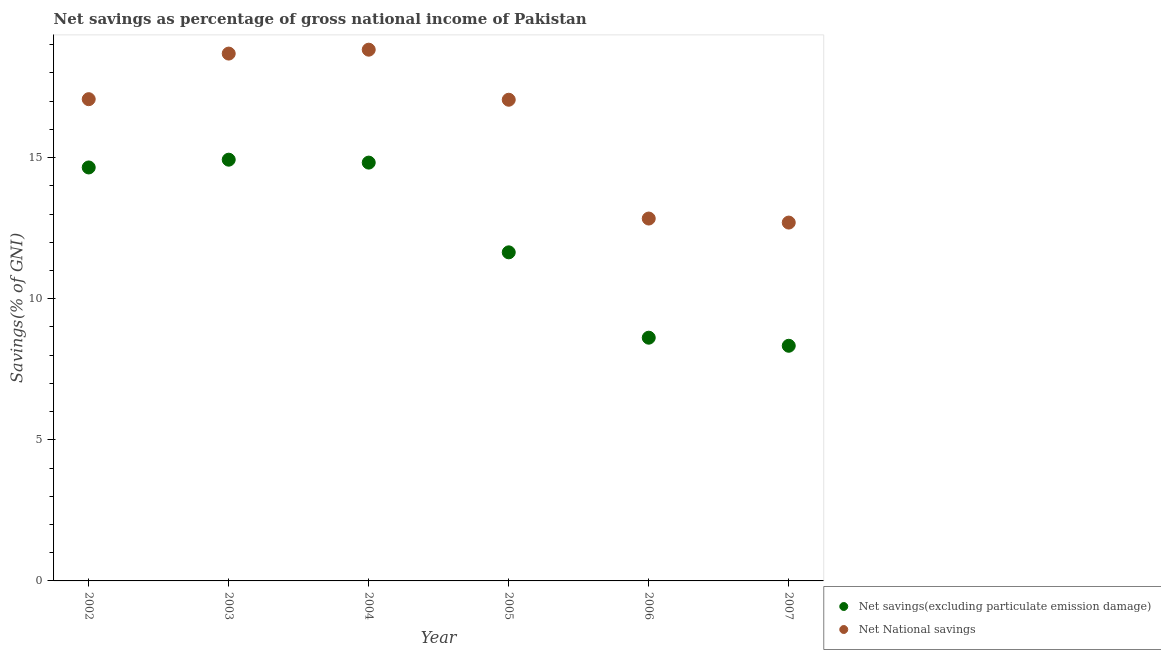Is the number of dotlines equal to the number of legend labels?
Give a very brief answer. Yes. What is the net national savings in 2005?
Offer a very short reply. 17.05. Across all years, what is the maximum net savings(excluding particulate emission damage)?
Offer a very short reply. 14.93. Across all years, what is the minimum net savings(excluding particulate emission damage)?
Offer a very short reply. 8.33. In which year was the net national savings maximum?
Offer a very short reply. 2004. What is the total net national savings in the graph?
Your answer should be compact. 97.18. What is the difference between the net savings(excluding particulate emission damage) in 2006 and that in 2007?
Your answer should be compact. 0.29. What is the difference between the net national savings in 2003 and the net savings(excluding particulate emission damage) in 2006?
Your response must be concise. 10.07. What is the average net savings(excluding particulate emission damage) per year?
Keep it short and to the point. 12.17. In the year 2002, what is the difference between the net national savings and net savings(excluding particulate emission damage)?
Your response must be concise. 2.42. In how many years, is the net national savings greater than 8 %?
Provide a succinct answer. 6. What is the ratio of the net national savings in 2002 to that in 2007?
Ensure brevity in your answer.  1.34. Is the net savings(excluding particulate emission damage) in 2002 less than that in 2007?
Provide a succinct answer. No. What is the difference between the highest and the second highest net savings(excluding particulate emission damage)?
Keep it short and to the point. 0.1. What is the difference between the highest and the lowest net savings(excluding particulate emission damage)?
Offer a very short reply. 6.59. In how many years, is the net savings(excluding particulate emission damage) greater than the average net savings(excluding particulate emission damage) taken over all years?
Give a very brief answer. 3. Does the net national savings monotonically increase over the years?
Give a very brief answer. No. Is the net national savings strictly less than the net savings(excluding particulate emission damage) over the years?
Keep it short and to the point. No. How many years are there in the graph?
Offer a very short reply. 6. What is the difference between two consecutive major ticks on the Y-axis?
Make the answer very short. 5. Are the values on the major ticks of Y-axis written in scientific E-notation?
Your answer should be compact. No. Does the graph contain any zero values?
Your answer should be very brief. No. Where does the legend appear in the graph?
Ensure brevity in your answer.  Bottom right. How are the legend labels stacked?
Your answer should be compact. Vertical. What is the title of the graph?
Provide a succinct answer. Net savings as percentage of gross national income of Pakistan. What is the label or title of the Y-axis?
Offer a very short reply. Savings(% of GNI). What is the Savings(% of GNI) in Net savings(excluding particulate emission damage) in 2002?
Ensure brevity in your answer.  14.65. What is the Savings(% of GNI) in Net National savings in 2002?
Your response must be concise. 17.07. What is the Savings(% of GNI) in Net savings(excluding particulate emission damage) in 2003?
Give a very brief answer. 14.93. What is the Savings(% of GNI) of Net National savings in 2003?
Your answer should be very brief. 18.69. What is the Savings(% of GNI) in Net savings(excluding particulate emission damage) in 2004?
Provide a succinct answer. 14.82. What is the Savings(% of GNI) in Net National savings in 2004?
Make the answer very short. 18.83. What is the Savings(% of GNI) in Net savings(excluding particulate emission damage) in 2005?
Offer a terse response. 11.64. What is the Savings(% of GNI) in Net National savings in 2005?
Make the answer very short. 17.05. What is the Savings(% of GNI) of Net savings(excluding particulate emission damage) in 2006?
Make the answer very short. 8.62. What is the Savings(% of GNI) in Net National savings in 2006?
Your response must be concise. 12.84. What is the Savings(% of GNI) of Net savings(excluding particulate emission damage) in 2007?
Keep it short and to the point. 8.33. What is the Savings(% of GNI) in Net National savings in 2007?
Offer a very short reply. 12.7. Across all years, what is the maximum Savings(% of GNI) in Net savings(excluding particulate emission damage)?
Offer a terse response. 14.93. Across all years, what is the maximum Savings(% of GNI) in Net National savings?
Provide a short and direct response. 18.83. Across all years, what is the minimum Savings(% of GNI) in Net savings(excluding particulate emission damage)?
Provide a short and direct response. 8.33. Across all years, what is the minimum Savings(% of GNI) of Net National savings?
Offer a terse response. 12.7. What is the total Savings(% of GNI) of Net savings(excluding particulate emission damage) in the graph?
Keep it short and to the point. 73. What is the total Savings(% of GNI) of Net National savings in the graph?
Ensure brevity in your answer.  97.18. What is the difference between the Savings(% of GNI) of Net savings(excluding particulate emission damage) in 2002 and that in 2003?
Make the answer very short. -0.28. What is the difference between the Savings(% of GNI) of Net National savings in 2002 and that in 2003?
Provide a succinct answer. -1.62. What is the difference between the Savings(% of GNI) of Net savings(excluding particulate emission damage) in 2002 and that in 2004?
Offer a very short reply. -0.17. What is the difference between the Savings(% of GNI) of Net National savings in 2002 and that in 2004?
Provide a succinct answer. -1.75. What is the difference between the Savings(% of GNI) of Net savings(excluding particulate emission damage) in 2002 and that in 2005?
Offer a very short reply. 3.01. What is the difference between the Savings(% of GNI) of Net National savings in 2002 and that in 2005?
Your answer should be compact. 0.02. What is the difference between the Savings(% of GNI) in Net savings(excluding particulate emission damage) in 2002 and that in 2006?
Provide a succinct answer. 6.03. What is the difference between the Savings(% of GNI) in Net National savings in 2002 and that in 2006?
Your response must be concise. 4.23. What is the difference between the Savings(% of GNI) in Net savings(excluding particulate emission damage) in 2002 and that in 2007?
Your answer should be compact. 6.32. What is the difference between the Savings(% of GNI) of Net National savings in 2002 and that in 2007?
Your answer should be compact. 4.37. What is the difference between the Savings(% of GNI) in Net savings(excluding particulate emission damage) in 2003 and that in 2004?
Your answer should be very brief. 0.1. What is the difference between the Savings(% of GNI) of Net National savings in 2003 and that in 2004?
Your response must be concise. -0.14. What is the difference between the Savings(% of GNI) of Net savings(excluding particulate emission damage) in 2003 and that in 2005?
Provide a short and direct response. 3.28. What is the difference between the Savings(% of GNI) in Net National savings in 2003 and that in 2005?
Provide a succinct answer. 1.64. What is the difference between the Savings(% of GNI) of Net savings(excluding particulate emission damage) in 2003 and that in 2006?
Offer a very short reply. 6.31. What is the difference between the Savings(% of GNI) of Net National savings in 2003 and that in 2006?
Your answer should be very brief. 5.85. What is the difference between the Savings(% of GNI) in Net savings(excluding particulate emission damage) in 2003 and that in 2007?
Offer a very short reply. 6.59. What is the difference between the Savings(% of GNI) in Net National savings in 2003 and that in 2007?
Offer a terse response. 5.99. What is the difference between the Savings(% of GNI) of Net savings(excluding particulate emission damage) in 2004 and that in 2005?
Offer a very short reply. 3.18. What is the difference between the Savings(% of GNI) of Net National savings in 2004 and that in 2005?
Offer a terse response. 1.77. What is the difference between the Savings(% of GNI) of Net savings(excluding particulate emission damage) in 2004 and that in 2006?
Your answer should be compact. 6.2. What is the difference between the Savings(% of GNI) in Net National savings in 2004 and that in 2006?
Keep it short and to the point. 5.98. What is the difference between the Savings(% of GNI) of Net savings(excluding particulate emission damage) in 2004 and that in 2007?
Give a very brief answer. 6.49. What is the difference between the Savings(% of GNI) in Net National savings in 2004 and that in 2007?
Keep it short and to the point. 6.13. What is the difference between the Savings(% of GNI) in Net savings(excluding particulate emission damage) in 2005 and that in 2006?
Keep it short and to the point. 3.02. What is the difference between the Savings(% of GNI) in Net National savings in 2005 and that in 2006?
Keep it short and to the point. 4.21. What is the difference between the Savings(% of GNI) in Net savings(excluding particulate emission damage) in 2005 and that in 2007?
Provide a short and direct response. 3.31. What is the difference between the Savings(% of GNI) of Net National savings in 2005 and that in 2007?
Ensure brevity in your answer.  4.35. What is the difference between the Savings(% of GNI) of Net savings(excluding particulate emission damage) in 2006 and that in 2007?
Provide a short and direct response. 0.29. What is the difference between the Savings(% of GNI) in Net National savings in 2006 and that in 2007?
Keep it short and to the point. 0.14. What is the difference between the Savings(% of GNI) of Net savings(excluding particulate emission damage) in 2002 and the Savings(% of GNI) of Net National savings in 2003?
Make the answer very short. -4.04. What is the difference between the Savings(% of GNI) in Net savings(excluding particulate emission damage) in 2002 and the Savings(% of GNI) in Net National savings in 2004?
Your answer should be compact. -4.17. What is the difference between the Savings(% of GNI) in Net savings(excluding particulate emission damage) in 2002 and the Savings(% of GNI) in Net National savings in 2005?
Offer a very short reply. -2.4. What is the difference between the Savings(% of GNI) in Net savings(excluding particulate emission damage) in 2002 and the Savings(% of GNI) in Net National savings in 2006?
Keep it short and to the point. 1.81. What is the difference between the Savings(% of GNI) of Net savings(excluding particulate emission damage) in 2002 and the Savings(% of GNI) of Net National savings in 2007?
Provide a short and direct response. 1.95. What is the difference between the Savings(% of GNI) of Net savings(excluding particulate emission damage) in 2003 and the Savings(% of GNI) of Net National savings in 2004?
Offer a terse response. -3.9. What is the difference between the Savings(% of GNI) of Net savings(excluding particulate emission damage) in 2003 and the Savings(% of GNI) of Net National savings in 2005?
Offer a terse response. -2.12. What is the difference between the Savings(% of GNI) in Net savings(excluding particulate emission damage) in 2003 and the Savings(% of GNI) in Net National savings in 2006?
Make the answer very short. 2.09. What is the difference between the Savings(% of GNI) in Net savings(excluding particulate emission damage) in 2003 and the Savings(% of GNI) in Net National savings in 2007?
Offer a terse response. 2.23. What is the difference between the Savings(% of GNI) in Net savings(excluding particulate emission damage) in 2004 and the Savings(% of GNI) in Net National savings in 2005?
Give a very brief answer. -2.23. What is the difference between the Savings(% of GNI) of Net savings(excluding particulate emission damage) in 2004 and the Savings(% of GNI) of Net National savings in 2006?
Provide a short and direct response. 1.98. What is the difference between the Savings(% of GNI) of Net savings(excluding particulate emission damage) in 2004 and the Savings(% of GNI) of Net National savings in 2007?
Your answer should be very brief. 2.13. What is the difference between the Savings(% of GNI) of Net savings(excluding particulate emission damage) in 2005 and the Savings(% of GNI) of Net National savings in 2006?
Make the answer very short. -1.2. What is the difference between the Savings(% of GNI) of Net savings(excluding particulate emission damage) in 2005 and the Savings(% of GNI) of Net National savings in 2007?
Give a very brief answer. -1.05. What is the difference between the Savings(% of GNI) of Net savings(excluding particulate emission damage) in 2006 and the Savings(% of GNI) of Net National savings in 2007?
Give a very brief answer. -4.08. What is the average Savings(% of GNI) in Net savings(excluding particulate emission damage) per year?
Provide a short and direct response. 12.17. What is the average Savings(% of GNI) of Net National savings per year?
Give a very brief answer. 16.2. In the year 2002, what is the difference between the Savings(% of GNI) of Net savings(excluding particulate emission damage) and Savings(% of GNI) of Net National savings?
Give a very brief answer. -2.42. In the year 2003, what is the difference between the Savings(% of GNI) in Net savings(excluding particulate emission damage) and Savings(% of GNI) in Net National savings?
Keep it short and to the point. -3.76. In the year 2004, what is the difference between the Savings(% of GNI) in Net savings(excluding particulate emission damage) and Savings(% of GNI) in Net National savings?
Keep it short and to the point. -4. In the year 2005, what is the difference between the Savings(% of GNI) of Net savings(excluding particulate emission damage) and Savings(% of GNI) of Net National savings?
Provide a short and direct response. -5.41. In the year 2006, what is the difference between the Savings(% of GNI) in Net savings(excluding particulate emission damage) and Savings(% of GNI) in Net National savings?
Your answer should be compact. -4.22. In the year 2007, what is the difference between the Savings(% of GNI) in Net savings(excluding particulate emission damage) and Savings(% of GNI) in Net National savings?
Make the answer very short. -4.37. What is the ratio of the Savings(% of GNI) of Net savings(excluding particulate emission damage) in 2002 to that in 2003?
Provide a short and direct response. 0.98. What is the ratio of the Savings(% of GNI) in Net National savings in 2002 to that in 2003?
Ensure brevity in your answer.  0.91. What is the ratio of the Savings(% of GNI) of Net savings(excluding particulate emission damage) in 2002 to that in 2004?
Give a very brief answer. 0.99. What is the ratio of the Savings(% of GNI) in Net National savings in 2002 to that in 2004?
Provide a succinct answer. 0.91. What is the ratio of the Savings(% of GNI) in Net savings(excluding particulate emission damage) in 2002 to that in 2005?
Your answer should be compact. 1.26. What is the ratio of the Savings(% of GNI) in Net National savings in 2002 to that in 2005?
Give a very brief answer. 1. What is the ratio of the Savings(% of GNI) in Net savings(excluding particulate emission damage) in 2002 to that in 2006?
Provide a short and direct response. 1.7. What is the ratio of the Savings(% of GNI) of Net National savings in 2002 to that in 2006?
Your answer should be compact. 1.33. What is the ratio of the Savings(% of GNI) of Net savings(excluding particulate emission damage) in 2002 to that in 2007?
Ensure brevity in your answer.  1.76. What is the ratio of the Savings(% of GNI) of Net National savings in 2002 to that in 2007?
Provide a short and direct response. 1.34. What is the ratio of the Savings(% of GNI) of Net National savings in 2003 to that in 2004?
Offer a very short reply. 0.99. What is the ratio of the Savings(% of GNI) of Net savings(excluding particulate emission damage) in 2003 to that in 2005?
Your answer should be compact. 1.28. What is the ratio of the Savings(% of GNI) in Net National savings in 2003 to that in 2005?
Give a very brief answer. 1.1. What is the ratio of the Savings(% of GNI) in Net savings(excluding particulate emission damage) in 2003 to that in 2006?
Give a very brief answer. 1.73. What is the ratio of the Savings(% of GNI) of Net National savings in 2003 to that in 2006?
Your response must be concise. 1.46. What is the ratio of the Savings(% of GNI) of Net savings(excluding particulate emission damage) in 2003 to that in 2007?
Your answer should be compact. 1.79. What is the ratio of the Savings(% of GNI) in Net National savings in 2003 to that in 2007?
Make the answer very short. 1.47. What is the ratio of the Savings(% of GNI) in Net savings(excluding particulate emission damage) in 2004 to that in 2005?
Offer a terse response. 1.27. What is the ratio of the Savings(% of GNI) in Net National savings in 2004 to that in 2005?
Your response must be concise. 1.1. What is the ratio of the Savings(% of GNI) in Net savings(excluding particulate emission damage) in 2004 to that in 2006?
Make the answer very short. 1.72. What is the ratio of the Savings(% of GNI) in Net National savings in 2004 to that in 2006?
Provide a short and direct response. 1.47. What is the ratio of the Savings(% of GNI) in Net savings(excluding particulate emission damage) in 2004 to that in 2007?
Your response must be concise. 1.78. What is the ratio of the Savings(% of GNI) in Net National savings in 2004 to that in 2007?
Give a very brief answer. 1.48. What is the ratio of the Savings(% of GNI) in Net savings(excluding particulate emission damage) in 2005 to that in 2006?
Keep it short and to the point. 1.35. What is the ratio of the Savings(% of GNI) of Net National savings in 2005 to that in 2006?
Your response must be concise. 1.33. What is the ratio of the Savings(% of GNI) in Net savings(excluding particulate emission damage) in 2005 to that in 2007?
Your answer should be very brief. 1.4. What is the ratio of the Savings(% of GNI) in Net National savings in 2005 to that in 2007?
Your response must be concise. 1.34. What is the ratio of the Savings(% of GNI) in Net savings(excluding particulate emission damage) in 2006 to that in 2007?
Offer a very short reply. 1.03. What is the ratio of the Savings(% of GNI) in Net National savings in 2006 to that in 2007?
Your answer should be compact. 1.01. What is the difference between the highest and the second highest Savings(% of GNI) of Net savings(excluding particulate emission damage)?
Your answer should be compact. 0.1. What is the difference between the highest and the second highest Savings(% of GNI) of Net National savings?
Your answer should be compact. 0.14. What is the difference between the highest and the lowest Savings(% of GNI) of Net savings(excluding particulate emission damage)?
Your response must be concise. 6.59. What is the difference between the highest and the lowest Savings(% of GNI) in Net National savings?
Offer a very short reply. 6.13. 